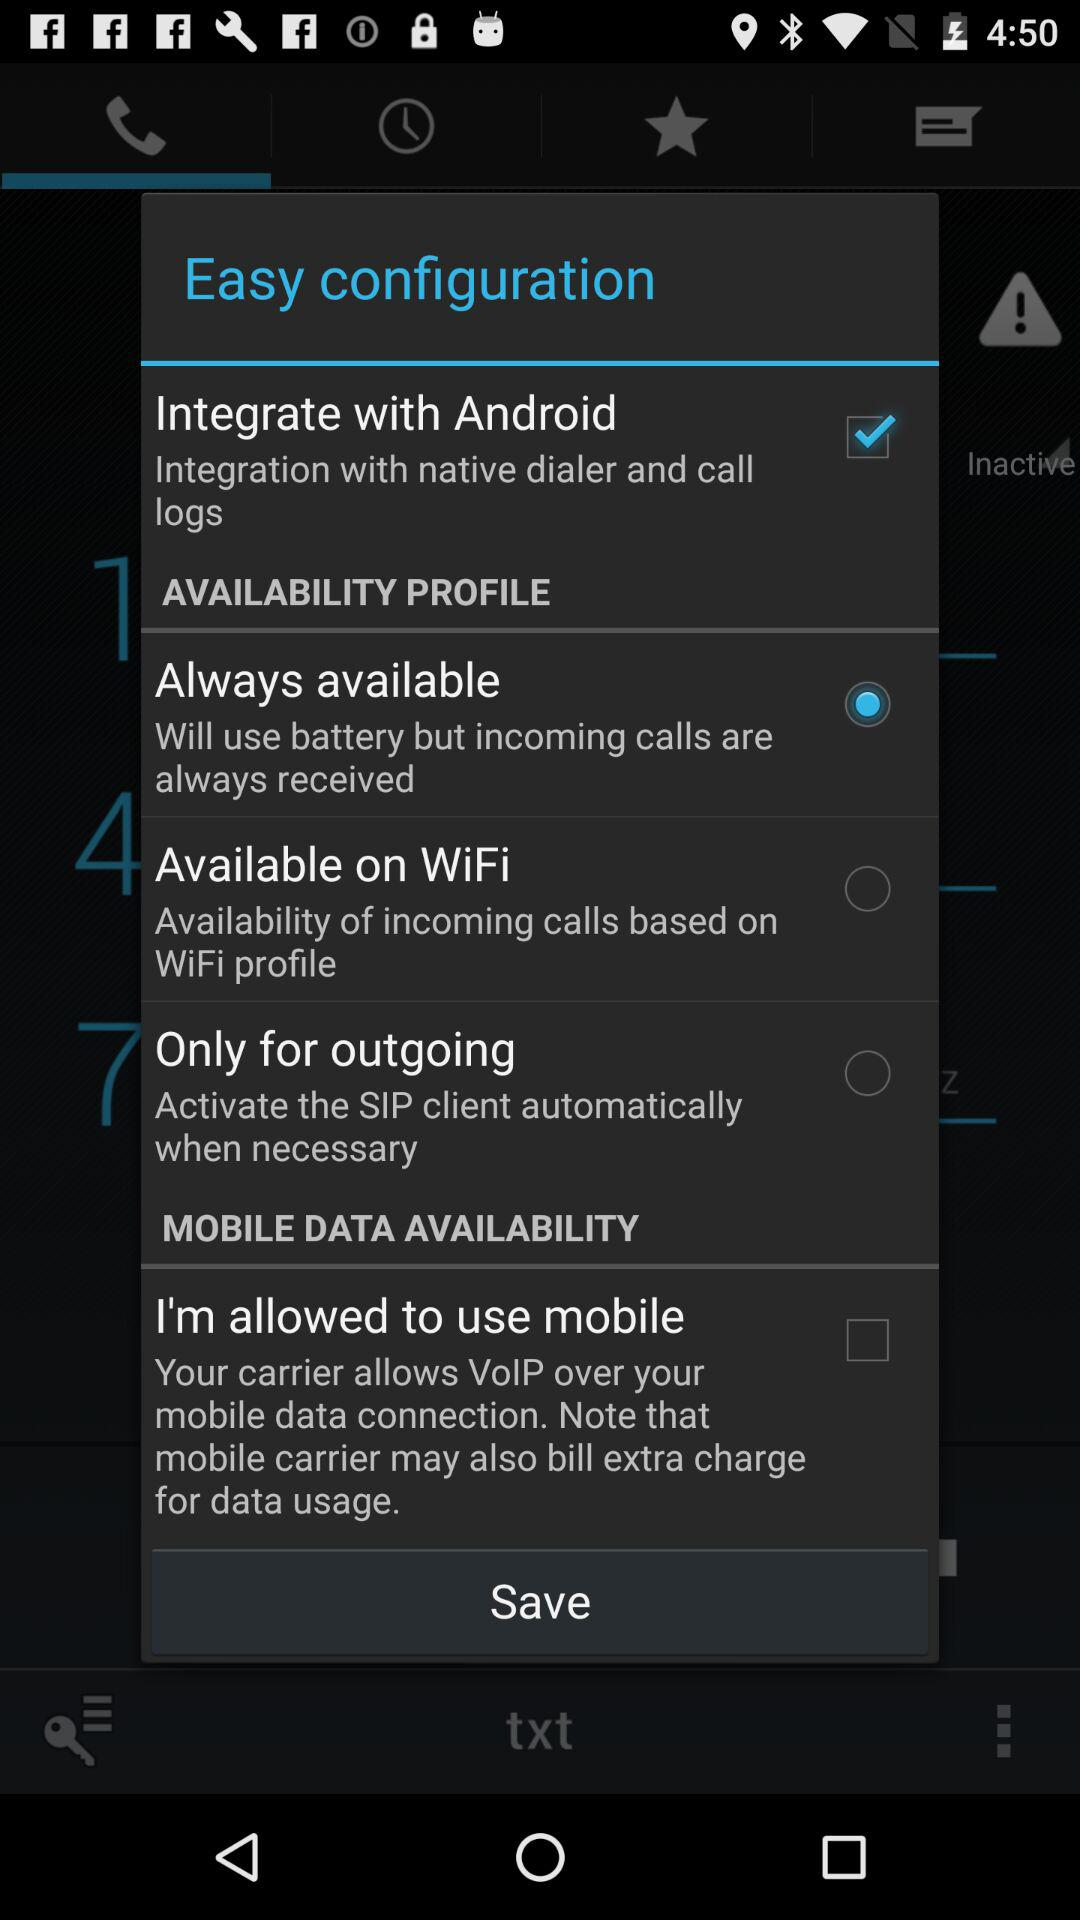Is the "Always available" feature selected or not?
Answer the question using a single word or phrase. It is selected. 